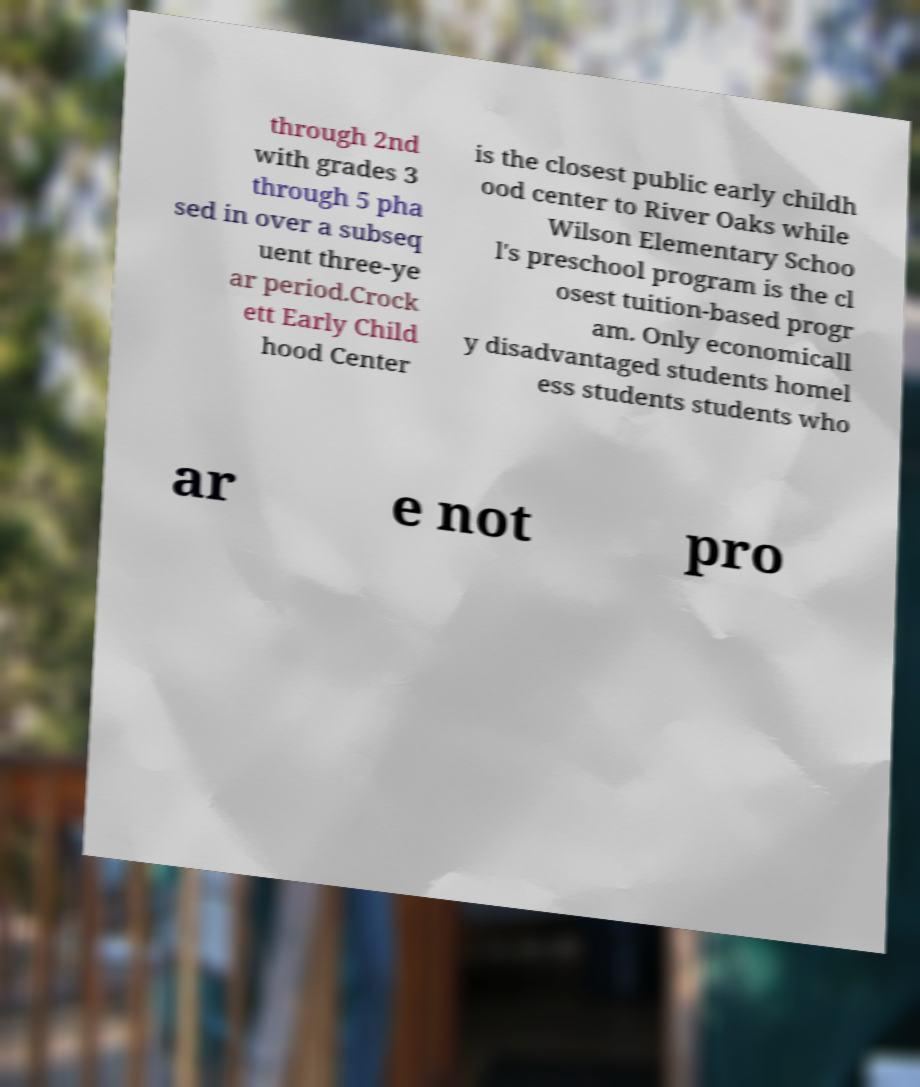There's text embedded in this image that I need extracted. Can you transcribe it verbatim? through 2nd with grades 3 through 5 pha sed in over a subseq uent three-ye ar period.Crock ett Early Child hood Center is the closest public early childh ood center to River Oaks while Wilson Elementary Schoo l's preschool program is the cl osest tuition-based progr am. Only economicall y disadvantaged students homel ess students students who ar e not pro 